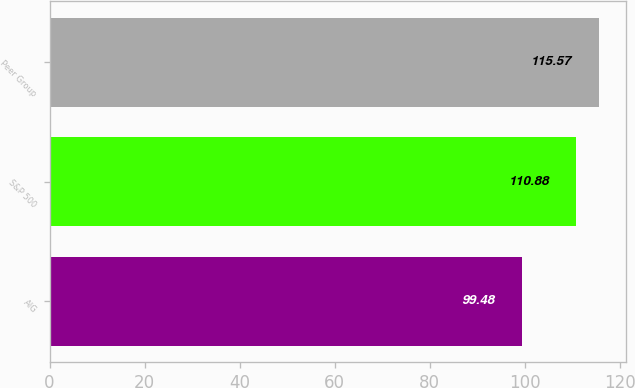Convert chart to OTSL. <chart><loc_0><loc_0><loc_500><loc_500><bar_chart><fcel>AIG<fcel>S&P 500<fcel>Peer Group<nl><fcel>99.48<fcel>110.88<fcel>115.57<nl></chart> 